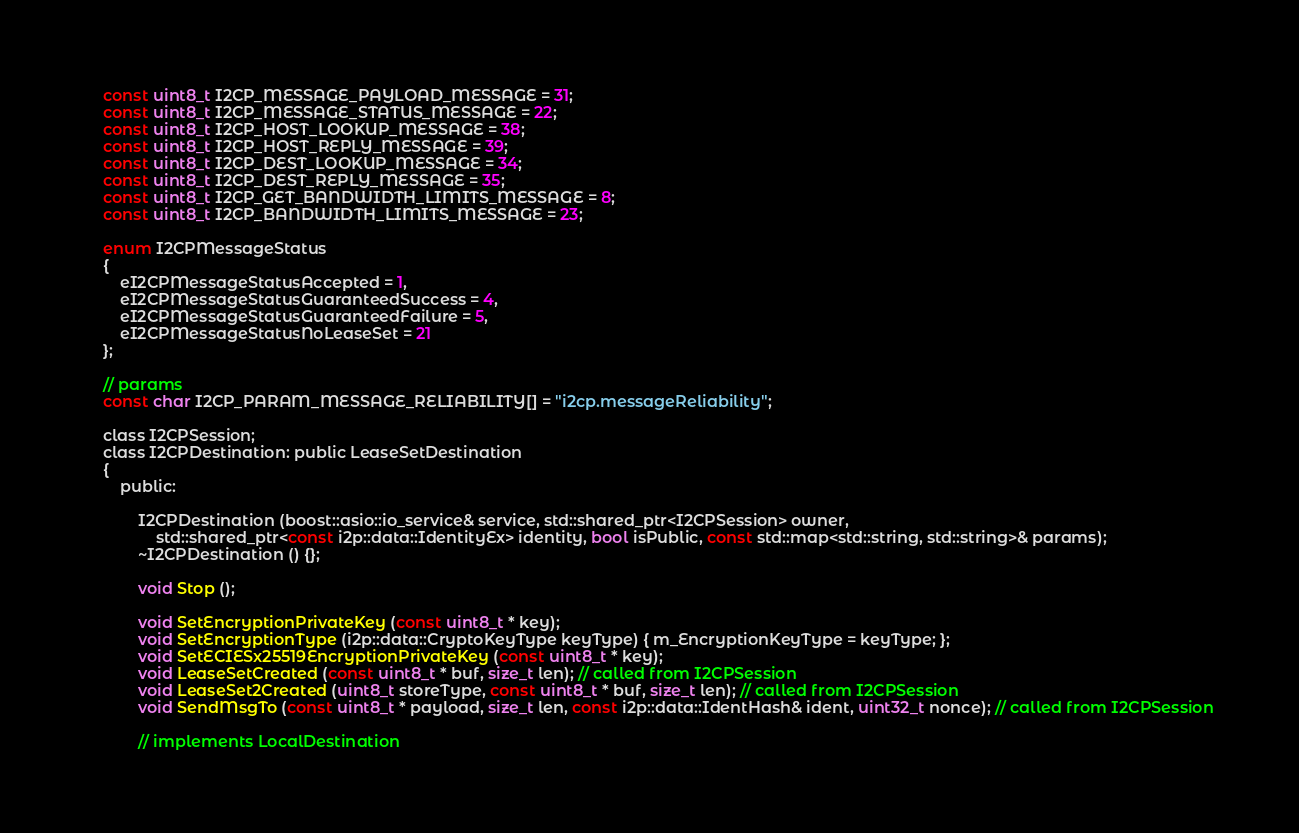<code> <loc_0><loc_0><loc_500><loc_500><_C_>	const uint8_t I2CP_MESSAGE_PAYLOAD_MESSAGE = 31;
	const uint8_t I2CP_MESSAGE_STATUS_MESSAGE = 22;
	const uint8_t I2CP_HOST_LOOKUP_MESSAGE = 38;
	const uint8_t I2CP_HOST_REPLY_MESSAGE = 39;
	const uint8_t I2CP_DEST_LOOKUP_MESSAGE = 34;
	const uint8_t I2CP_DEST_REPLY_MESSAGE = 35;
	const uint8_t I2CP_GET_BANDWIDTH_LIMITS_MESSAGE = 8;
	const uint8_t I2CP_BANDWIDTH_LIMITS_MESSAGE = 23;

	enum I2CPMessageStatus
	{
		eI2CPMessageStatusAccepted = 1,
		eI2CPMessageStatusGuaranteedSuccess = 4,
		eI2CPMessageStatusGuaranteedFailure = 5,
		eI2CPMessageStatusNoLeaseSet = 21
	};

	// params
	const char I2CP_PARAM_MESSAGE_RELIABILITY[] = "i2cp.messageReliability";

	class I2CPSession;
	class I2CPDestination: public LeaseSetDestination
	{
		public:

			I2CPDestination (boost::asio::io_service& service, std::shared_ptr<I2CPSession> owner, 
				std::shared_ptr<const i2p::data::IdentityEx> identity, bool isPublic, const std::map<std::string, std::string>& params);
			~I2CPDestination () {};

			void Stop ();
			
			void SetEncryptionPrivateKey (const uint8_t * key);
			void SetEncryptionType (i2p::data::CryptoKeyType keyType) { m_EncryptionKeyType = keyType; };
			void SetECIESx25519EncryptionPrivateKey (const uint8_t * key);
			void LeaseSetCreated (const uint8_t * buf, size_t len); // called from I2CPSession
			void LeaseSet2Created (uint8_t storeType, const uint8_t * buf, size_t len); // called from I2CPSession
			void SendMsgTo (const uint8_t * payload, size_t len, const i2p::data::IdentHash& ident, uint32_t nonce); // called from I2CPSession

			// implements LocalDestination</code> 